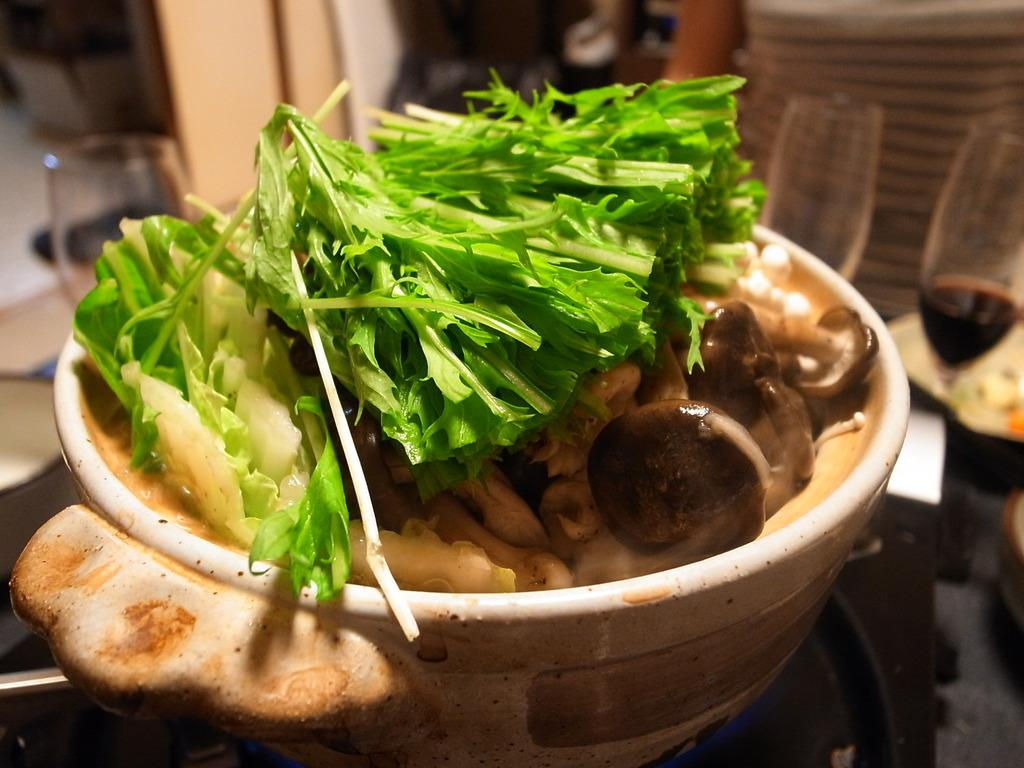What is in the bowl that is visible in the image? The bowl contains boiled mushrooms and boiled spinach. What else can be seen in the image besides the bowl? There are wine glasses filled with wine in the image. Where are the wine glasses located? The wine glasses are on a table. What type of net is being used to catch the writer in the image? A: There is no writer or net present in the image. What type of apparel is the mushroom wearing in the image? The mushrooms are not wearing any apparel in the image, as they are food items. 